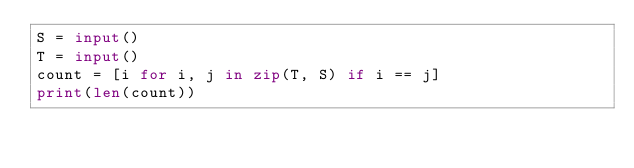Convert code to text. <code><loc_0><loc_0><loc_500><loc_500><_Python_>S = input()
T = input()
count = [i for i, j in zip(T, S) if i == j]
print(len(count))</code> 